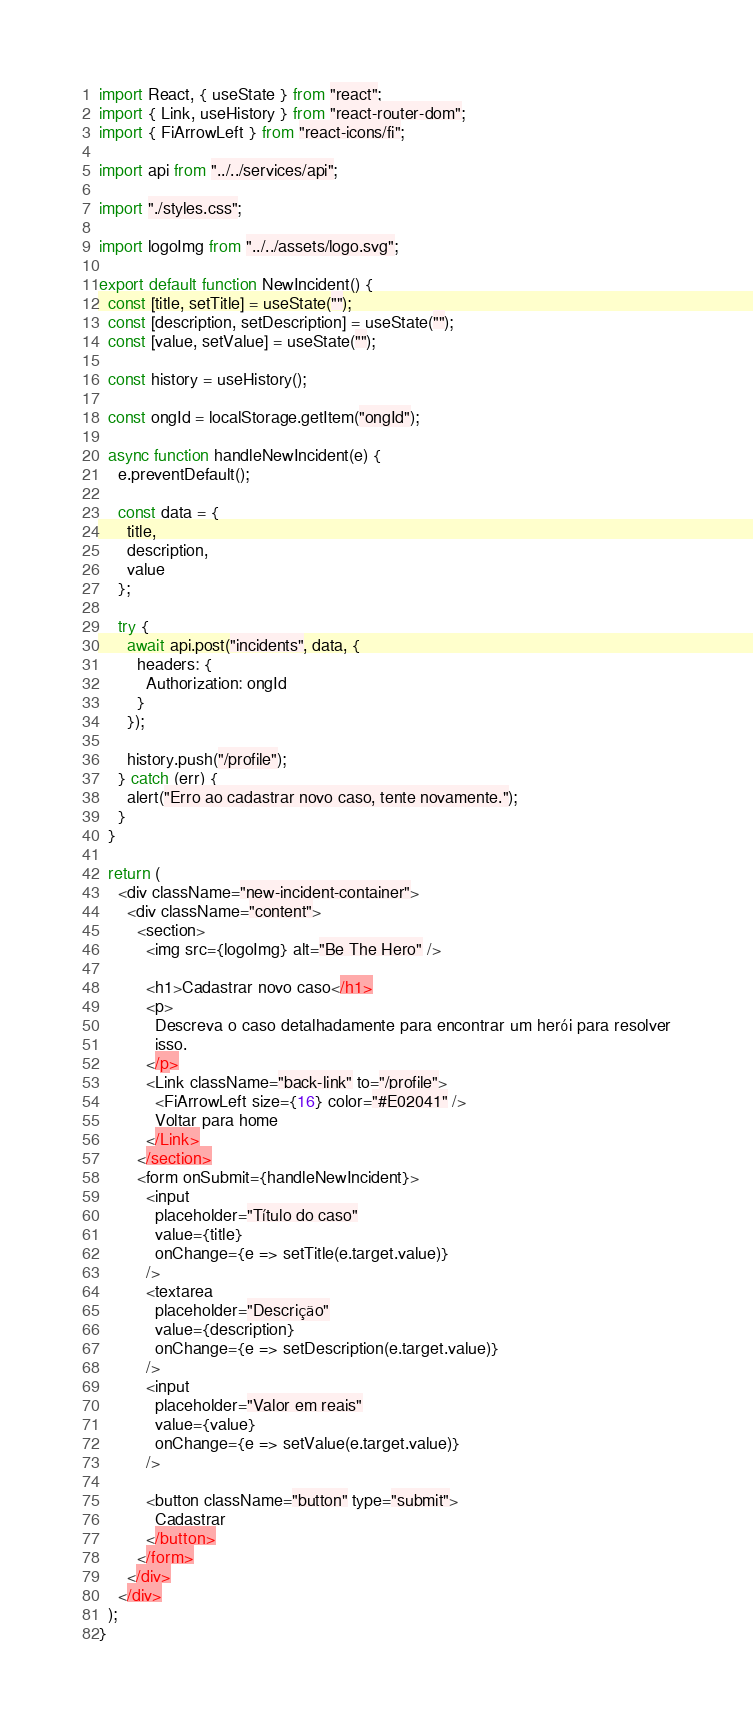Convert code to text. <code><loc_0><loc_0><loc_500><loc_500><_JavaScript_>import React, { useState } from "react";
import { Link, useHistory } from "react-router-dom";
import { FiArrowLeft } from "react-icons/fi";

import api from "../../services/api";

import "./styles.css";

import logoImg from "../../assets/logo.svg";

export default function NewIncident() {
  const [title, setTitle] = useState("");
  const [description, setDescription] = useState("");
  const [value, setValue] = useState("");

  const history = useHistory();

  const ongId = localStorage.getItem("ongId");

  async function handleNewIncident(e) {
    e.preventDefault();

    const data = {
      title,
      description,
      value
    };

    try {
      await api.post("incidents", data, {
        headers: {
          Authorization: ongId
        }
      });

      history.push("/profile");
    } catch (err) {
      alert("Erro ao cadastrar novo caso, tente novamente.");
    }
  }

  return (
    <div className="new-incident-container">
      <div className="content">
        <section>
          <img src={logoImg} alt="Be The Hero" />

          <h1>Cadastrar novo caso</h1>
          <p>
            Descreva o caso detalhadamente para encontrar um herói para resolver
            isso.
          </p>
          <Link className="back-link" to="/profile">
            <FiArrowLeft size={16} color="#E02041" />
            Voltar para home
          </Link>
        </section>
        <form onSubmit={handleNewIncident}>
          <input
            placeholder="Título do caso"
            value={title}
            onChange={e => setTitle(e.target.value)}
          />
          <textarea
            placeholder="Descrição"
            value={description}
            onChange={e => setDescription(e.target.value)}
          />
          <input
            placeholder="Valor em reais"
            value={value}
            onChange={e => setValue(e.target.value)}
          />

          <button className="button" type="submit">
            Cadastrar
          </button>
        </form>
      </div>
    </div>
  );
}
</code> 